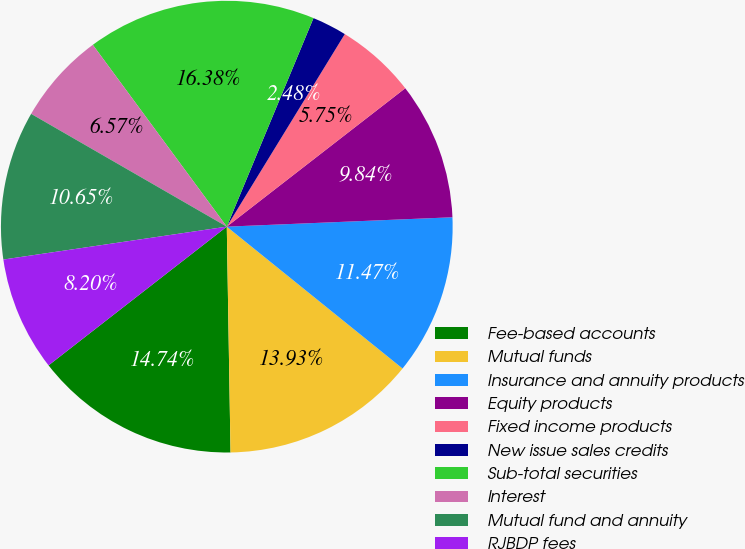<chart> <loc_0><loc_0><loc_500><loc_500><pie_chart><fcel>Fee-based accounts<fcel>Mutual funds<fcel>Insurance and annuity products<fcel>Equity products<fcel>Fixed income products<fcel>New issue sales credits<fcel>Sub-total securities<fcel>Interest<fcel>Mutual fund and annuity<fcel>RJBDP fees<nl><fcel>14.74%<fcel>13.93%<fcel>11.47%<fcel>9.84%<fcel>5.75%<fcel>2.48%<fcel>16.38%<fcel>6.57%<fcel>10.65%<fcel>8.2%<nl></chart> 